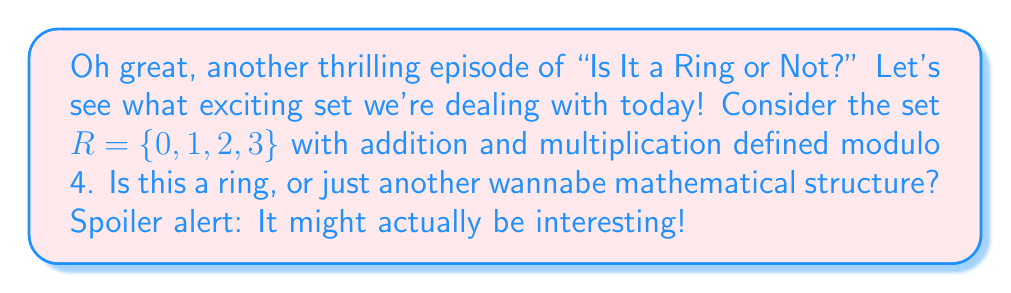What is the answer to this math problem? Alright, gather 'round for the nail-biting analysis of our potential ring superstar:

1) Closure: 
   For addition and multiplication modulo 4, all results stay within our set. It's like a mathematical hotel California - they can never leave!

2) Associativity:
   $(a + b) + c \equiv a + (b + c) \pmod{4}$
   $(a \cdot b) \cdot c \equiv a \cdot (b \cdot c) \pmod{4}$
   This holds for all elements. It's almost as if they planned this...

3) Commutativity:
   $a + b \equiv b + a \pmod{4}$
   $a \cdot b \equiv b \cdot a \pmod{4}$
   They're playing musical chairs, and everyone's a winner!

4) Additive Identity:
   $0 + a \equiv a \pmod{4}$ for all $a \in R$
   Zero, the unsung hero of addition.

5) Additive Inverse:
   For each $a \in R$, there exists $-a \in R$ such that $a + (-a) \equiv 0 \pmod{4}$
   $-0 = 0$, $-1 = 3$, $-2 = 2$, $-3 = 1$
   Every element has its perfect opposite. It's like a mathematical soap opera!

6) Multiplicative Identity:
   $1 \cdot a \equiv a \pmod{4}$ for all $a \in R$
   One, always trying to make others feel special.

7) Distributivity:
   $a \cdot (b + c) \equiv (a \cdot b) + (a \cdot c) \pmod{4}$
   It's spreading the love, mathematically speaking.

Well, well, well... looks like we've hit the jackpot! This set checks all the boxes. It's closure, it's associative, it's commutative, it's got identities, inverses, and it's even distributive. It's the whole package!
Answer: Yes, the set $R = \{0, 1, 2, 3\}$ with addition and multiplication modulo 4 forms a ring. It satisfies all the ring axioms: closure, associativity, commutativity, additive identity, additive inverse, multiplicative identity, and distributivity. 